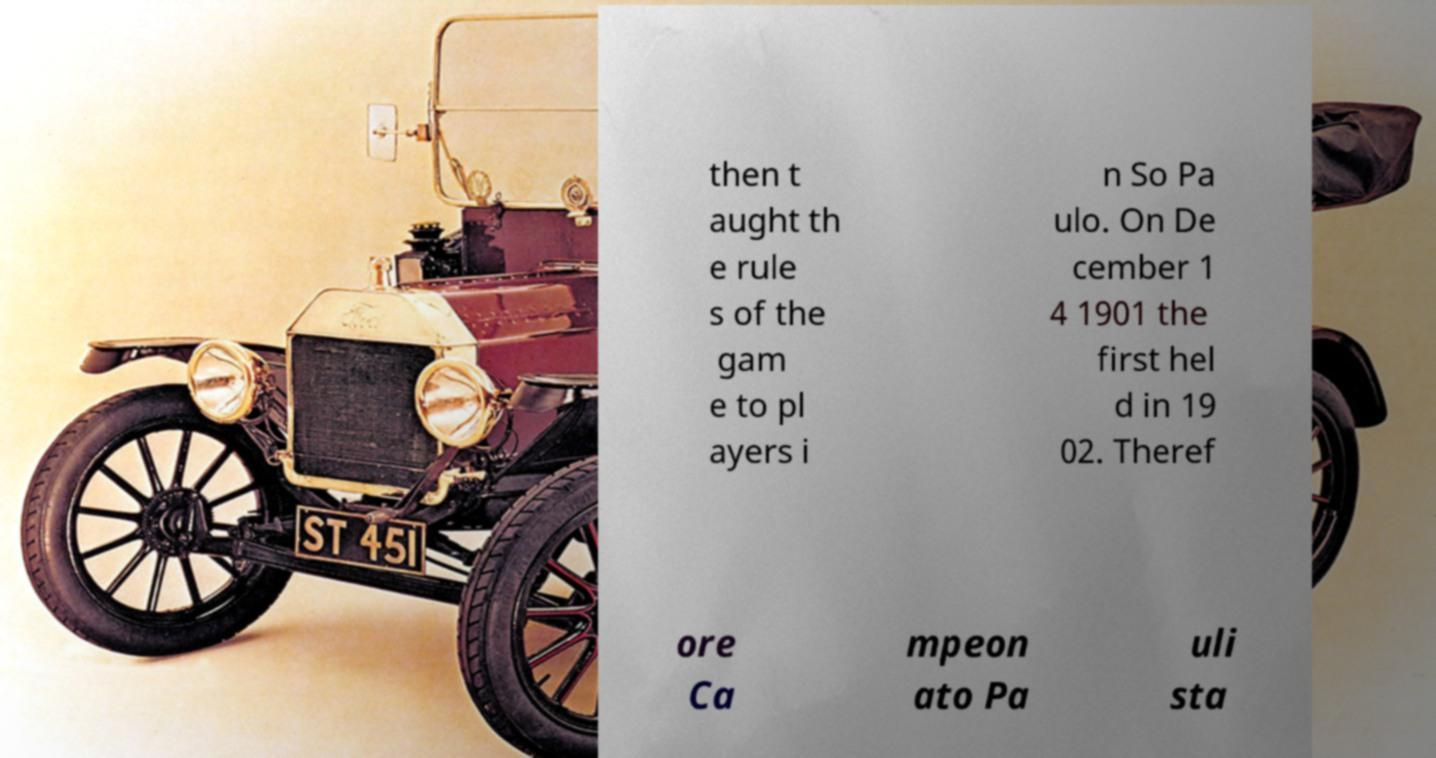Could you assist in decoding the text presented in this image and type it out clearly? then t aught th e rule s of the gam e to pl ayers i n So Pa ulo. On De cember 1 4 1901 the first hel d in 19 02. Theref ore Ca mpeon ato Pa uli sta 